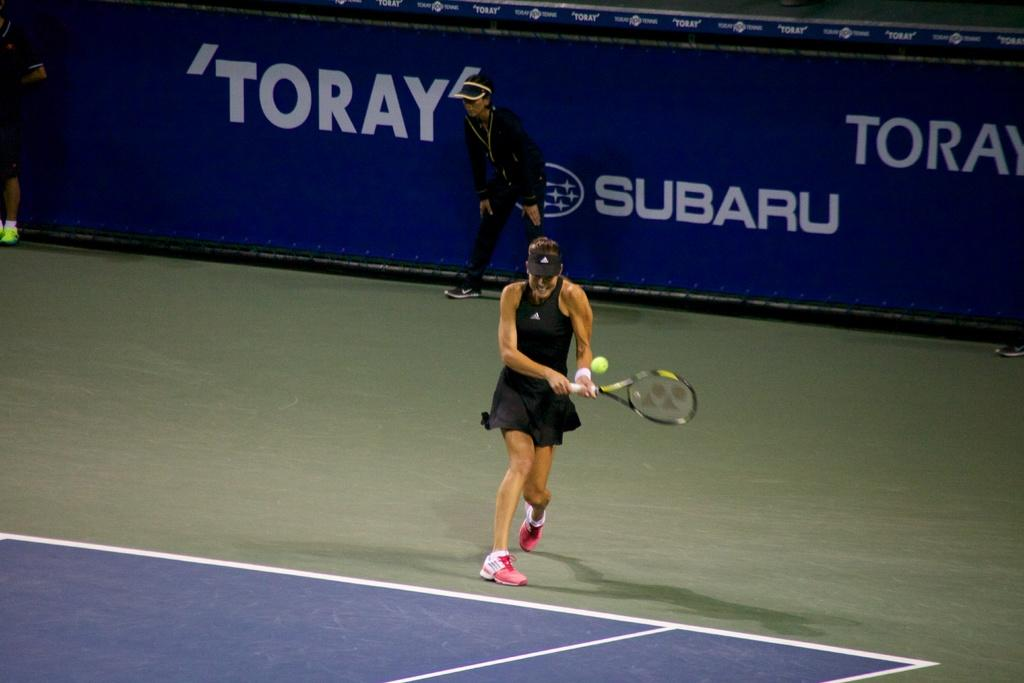Who is the main subject in the image? There is a woman in the image. What is the woman wearing? The woman is wearing a black dress. What object is the woman holding? The woman is holding a tennis racket. What activity is the woman engaged in? The woman is playing tennis. Can you describe the setting of the image? The scene takes place on a tennis court. What else can be seen in the background of the image? There is a banner in the background. What type of lettuce can be seen growing on the tennis court in the image? There is no lettuce present in the image, and the scene takes place on a tennis court, not a garden. 